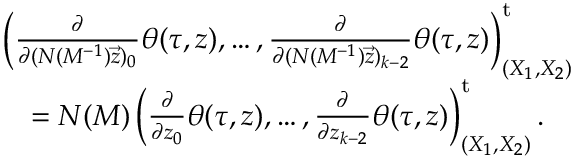<formula> <loc_0><loc_0><loc_500><loc_500>\begin{array} { r l } & { \left ( \frac { \partial } { \partial ( N ( M ^ { - 1 } ) \vec { z } ) _ { 0 } } \theta ( \tau , z ) , \dots , \frac { \partial } { \partial ( N ( M ^ { - 1 } ) \vec { z } ) _ { k - 2 } } \theta ( \tau , z ) \right ) _ { ( X _ { 1 } , X _ { 2 } ) } ^ { t } } \\ & { \quad = N ( M ) \left ( \frac { \partial } { \partial z _ { 0 } } \theta ( \tau , z ) , \dots , \frac { \partial } { \partial z _ { k - 2 } } \theta ( \tau , z ) \right ) _ { ( X _ { 1 } , X _ { 2 } ) } ^ { t } . } \end{array}</formula> 